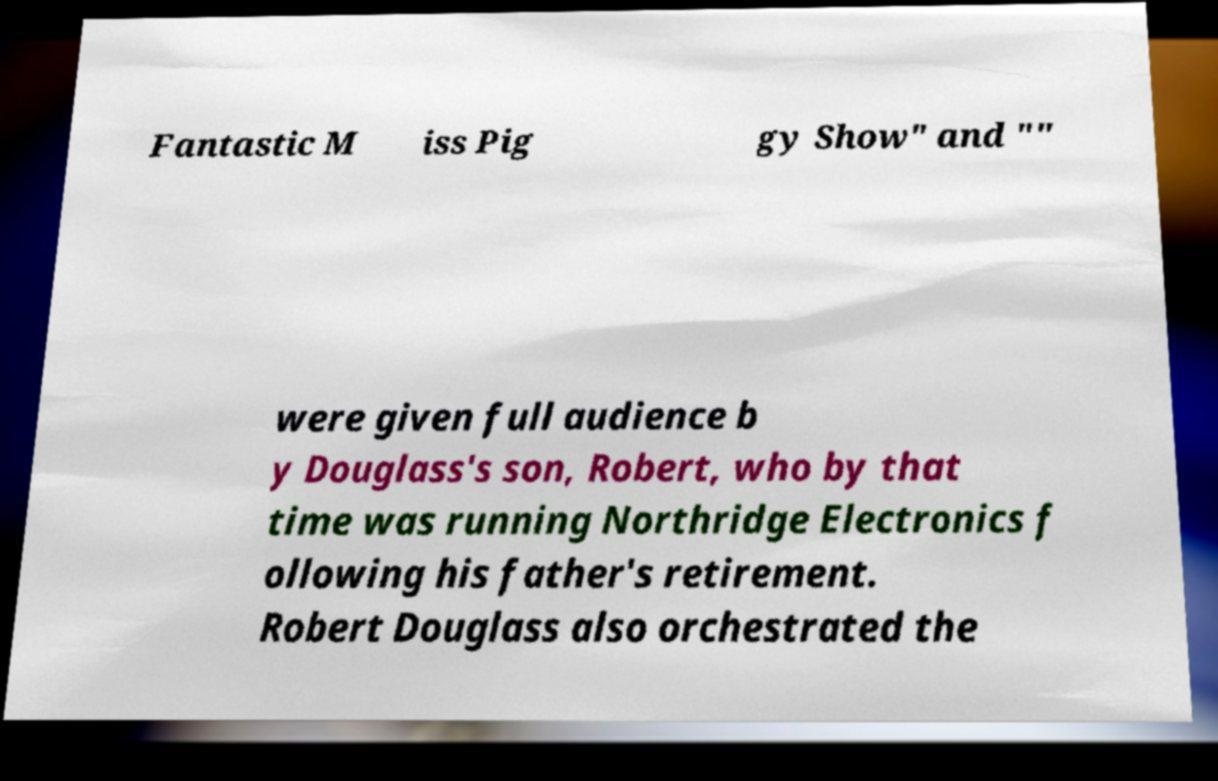What messages or text are displayed in this image? I need them in a readable, typed format. Fantastic M iss Pig gy Show" and "" were given full audience b y Douglass's son, Robert, who by that time was running Northridge Electronics f ollowing his father's retirement. Robert Douglass also orchestrated the 